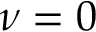<formula> <loc_0><loc_0><loc_500><loc_500>\nu = 0</formula> 